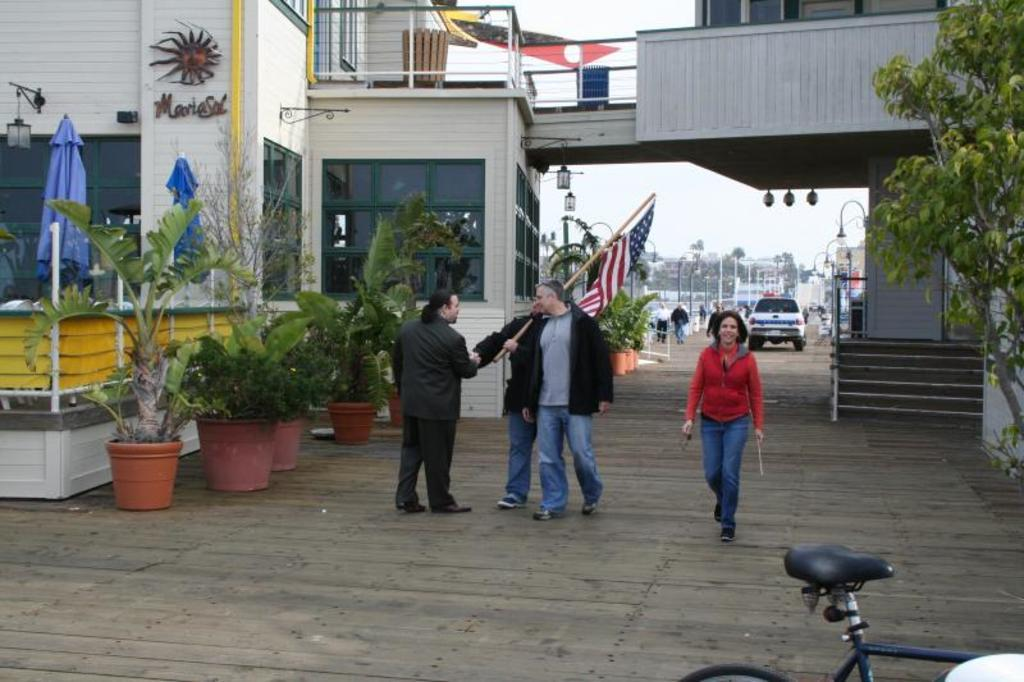What type of structures can be seen in the image? There are buildings in the image. What type of vegetation is present in the image? There are potted plants in the image. What are the people in the image doing? The people are standing and holding a flag. What type of watch can be seen on the wrist of the person holding the flag? There is no watch visible on the wrist of the person holding the flag in the image. What type of crack is present in the pavement near the buildings? There is no crack in the pavement visible in the image. 